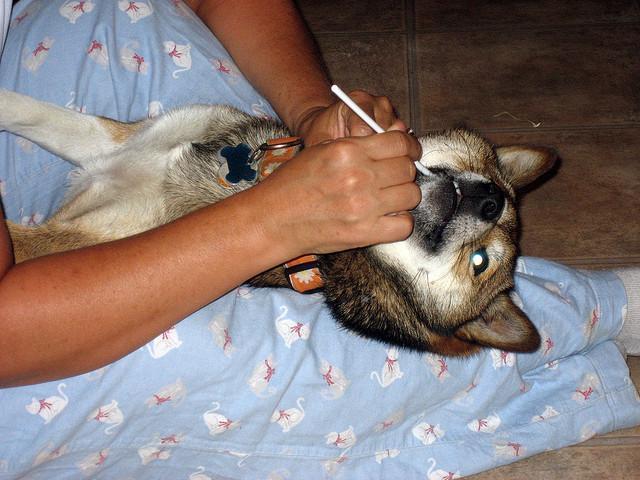How many orange balloons are in the picture?
Give a very brief answer. 0. 